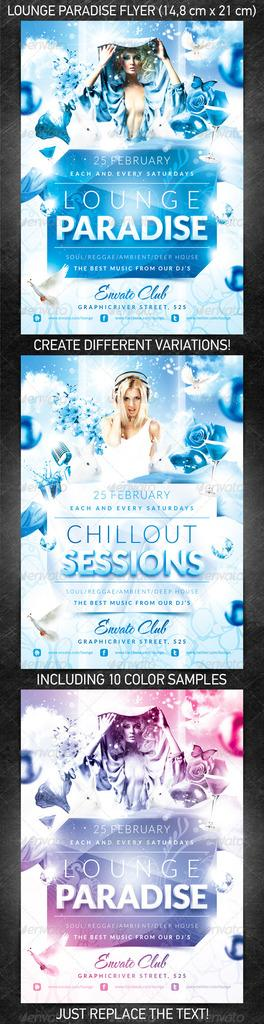Provide a one-sentence caption for the provided image. an item with Lounge Paradise written on it. 